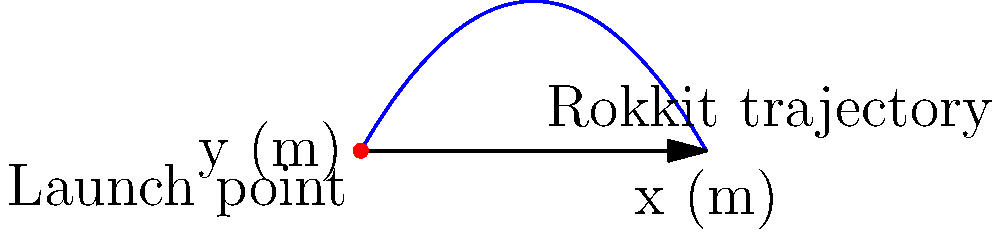An Ork Mek has launched a Rokkit with an initial velocity of 50 m/s at an angle of 60° above the horizontal. Assuming no air resistance and using a gravitational acceleration of 9.8 m/s², calculate the maximum height reached by the Rokkit. To find the maximum height of the Rokkit, we'll follow these steps:

1) First, we need to find the vertical component of the initial velocity:
   $v_{0y} = v_0 \sin(\theta) = 50 \sin(60°) = 43.3$ m/s

2) The maximum height is reached when the vertical velocity becomes zero. We can use the equation:
   $v_y^2 = v_{0y}^2 - 2gy$
   
   At the highest point, $v_y = 0$, so:
   $0 = v_{0y}^2 - 2gy_{max}$

3) Rearranging to solve for $y_{max}$:
   $y_{max} = \frac{v_{0y}^2}{2g}$

4) Substituting our values:
   $y_{max} = \frac{(43.3)^2}{2(9.8)} = 95.7$ m

Therefore, the Rokkit reaches a maximum height of approximately 95.7 meters.
Answer: 95.7 m 